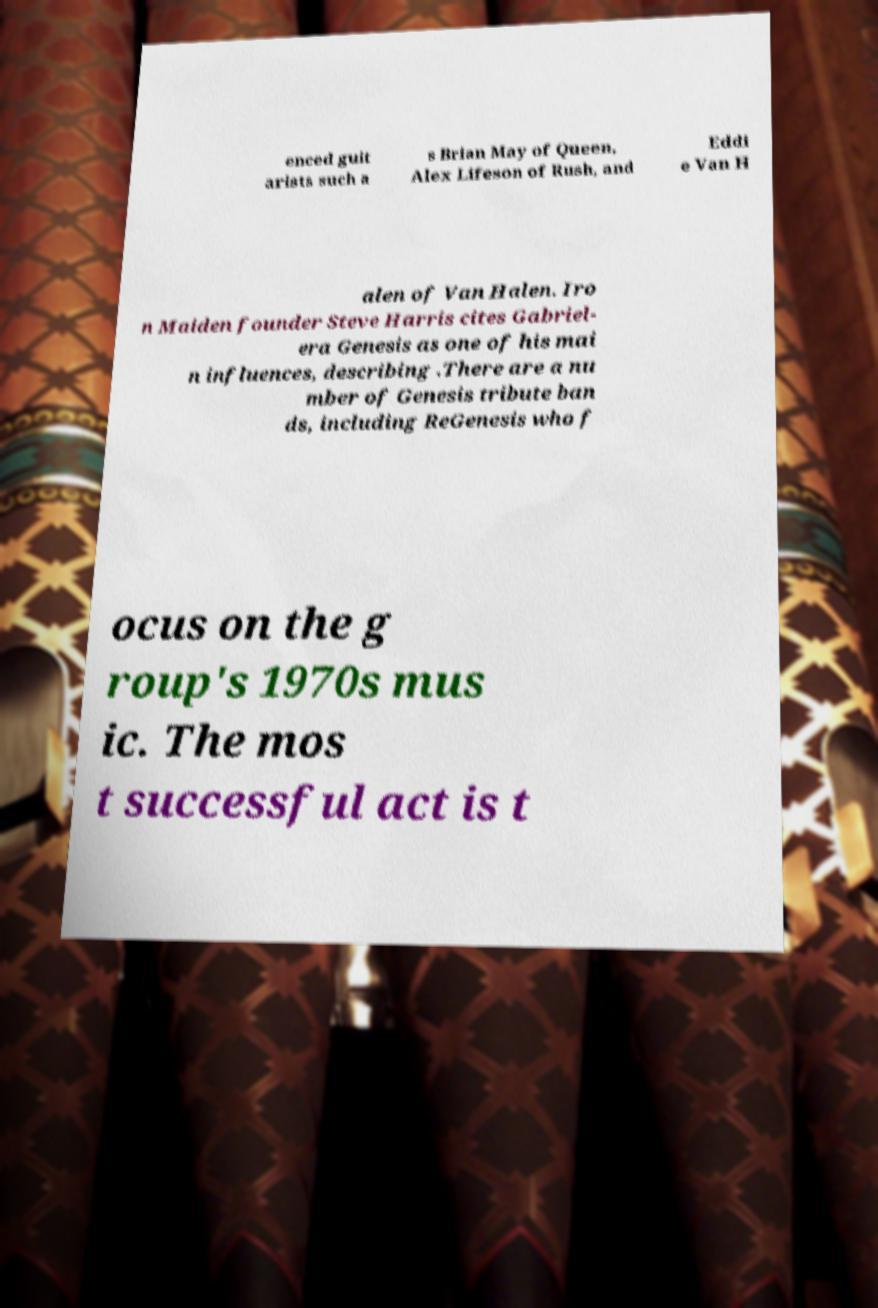I need the written content from this picture converted into text. Can you do that? enced guit arists such a s Brian May of Queen, Alex Lifeson of Rush, and Eddi e Van H alen of Van Halen. Iro n Maiden founder Steve Harris cites Gabriel- era Genesis as one of his mai n influences, describing .There are a nu mber of Genesis tribute ban ds, including ReGenesis who f ocus on the g roup's 1970s mus ic. The mos t successful act is t 